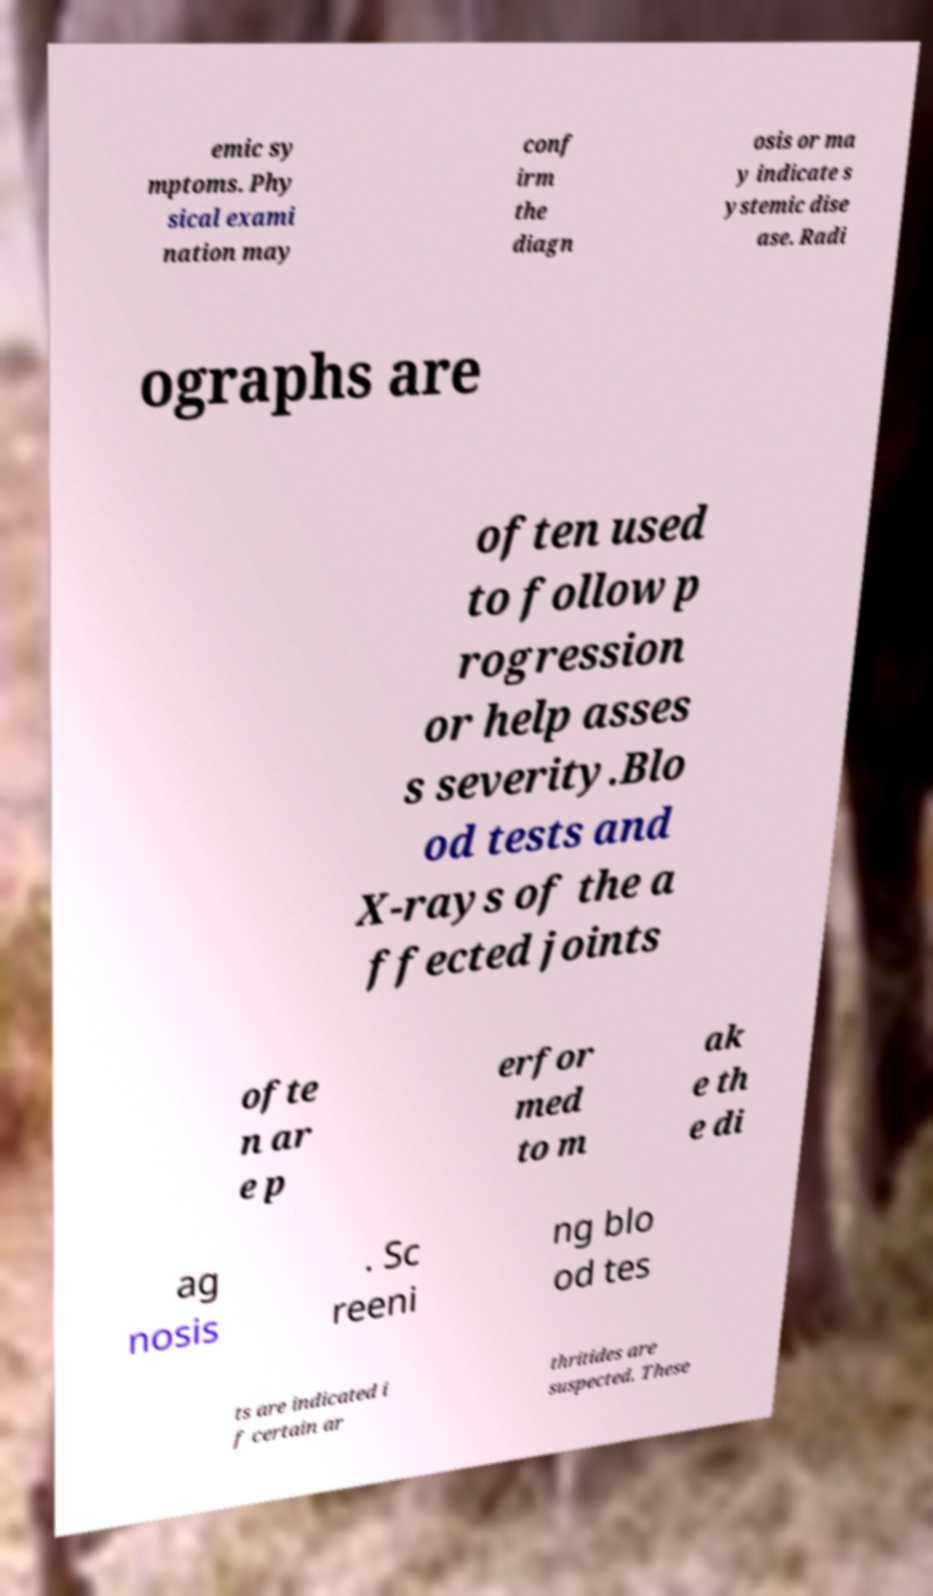What messages or text are displayed in this image? I need them in a readable, typed format. emic sy mptoms. Phy sical exami nation may conf irm the diagn osis or ma y indicate s ystemic dise ase. Radi ographs are often used to follow p rogression or help asses s severity.Blo od tests and X-rays of the a ffected joints ofte n ar e p erfor med to m ak e th e di ag nosis . Sc reeni ng blo od tes ts are indicated i f certain ar thritides are suspected. These 